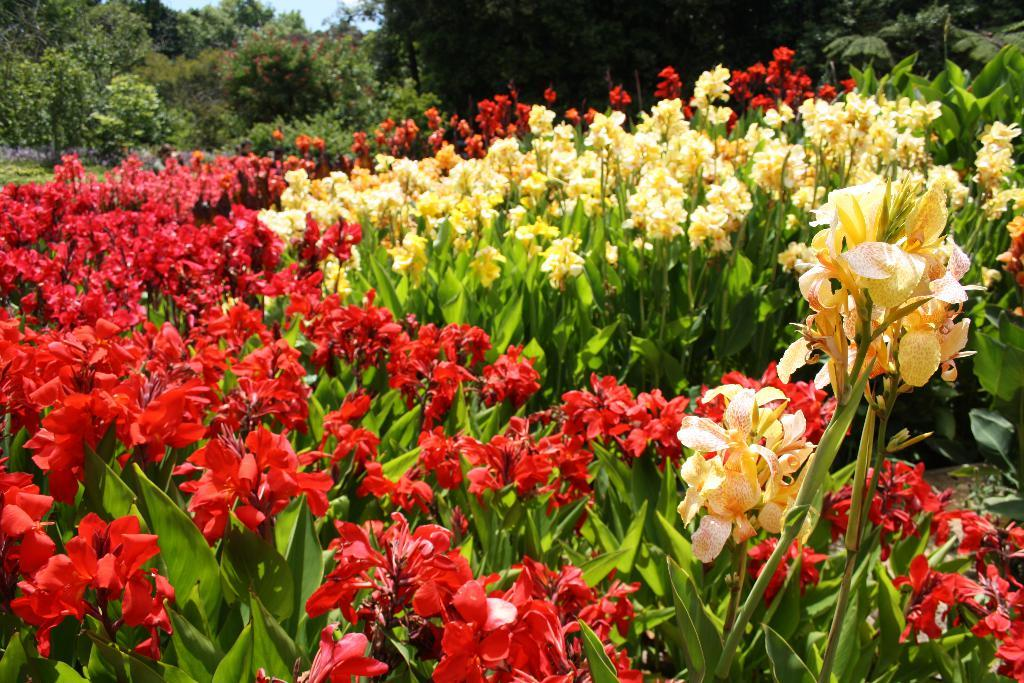What type of plants can be seen in the image? There are plants with flowers in the image. What colors are the flowers? The flowers are in red and yellow colors. What can be seen in the background of the image? There are trees in the background of the image. What type of sign can be seen near the plants in the image? There is no sign present near the plants in the image. Is there a crib visible in the image? No, there is no crib present in the image. 